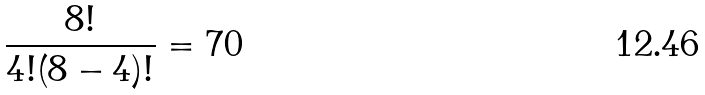Convert formula to latex. <formula><loc_0><loc_0><loc_500><loc_500>\frac { 8 ! } { 4 ! ( 8 - 4 ) ! } = 7 0</formula> 